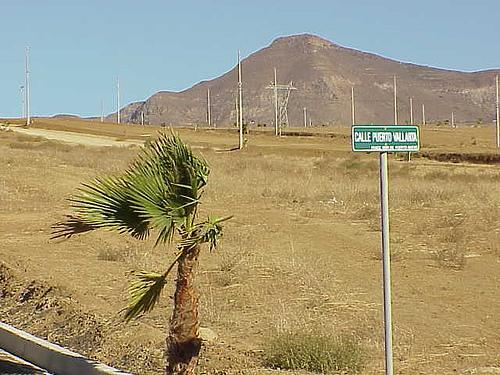What is the color of the weeds and grass?
Quick response, please. Brown. Is this the zoo?
Write a very short answer. No. What type of tree is in the photo?
Write a very short answer. Palm. What does the sign say?
Be succinct. Calle puerto vallarta. 